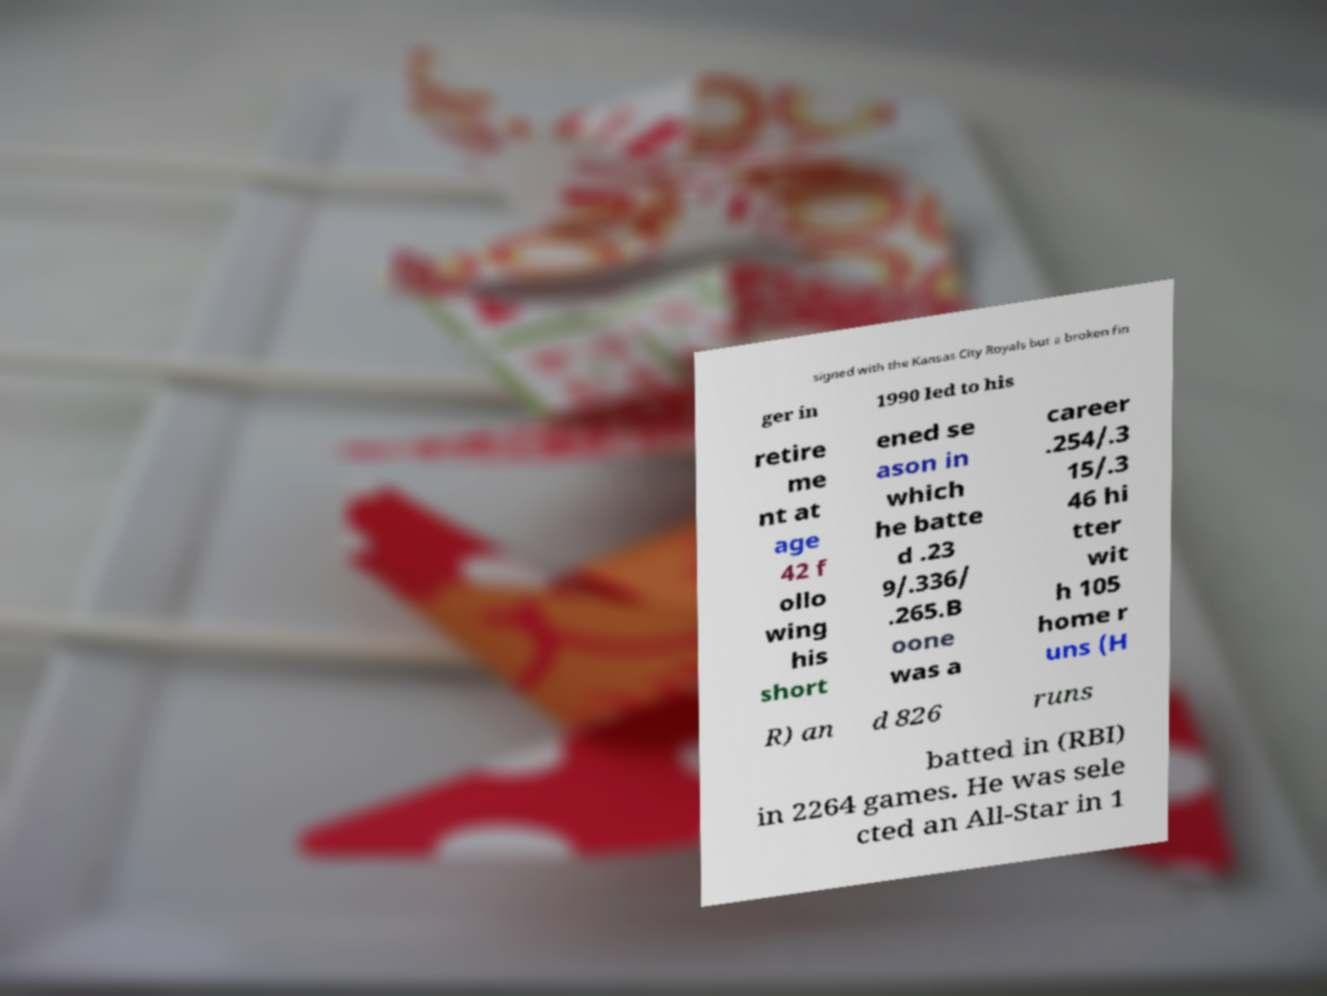There's text embedded in this image that I need extracted. Can you transcribe it verbatim? signed with the Kansas City Royals but a broken fin ger in 1990 led to his retire me nt at age 42 f ollo wing his short ened se ason in which he batte d .23 9/.336/ .265.B oone was a career .254/.3 15/.3 46 hi tter wit h 105 home r uns (H R) an d 826 runs batted in (RBI) in 2264 games. He was sele cted an All-Star in 1 